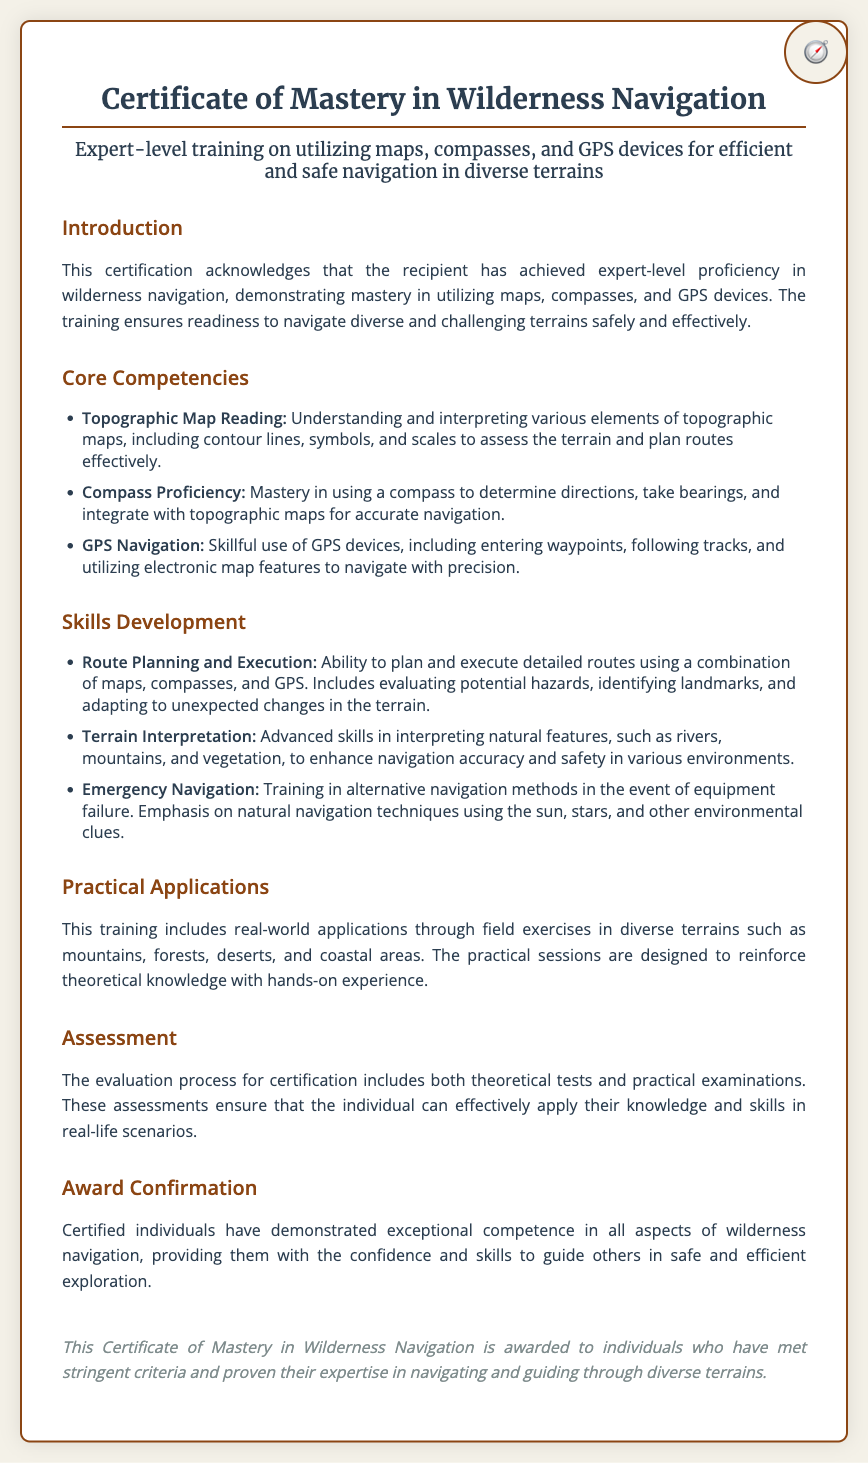What is the title of the certificate? The title is prominently displayed at the top of the document, indicating the purpose of the certification.
Answer: Certificate of Mastery in Wilderness Navigation What are the core competencies addressed? The document lists three core competencies under the corresponding section, providing insight into key skills.
Answer: Topographic Map Reading, Compass Proficiency, GPS Navigation How is assessment conducted for certification? The document specifies the evaluation process, noting the methods used to assess candidates.
Answer: Theoretical tests and practical examinations What is the focus of the training? The introductory section describes the main intent of the training provided through this certification.
Answer: Efficient and safe navigation in diverse terrains What does the emergency navigation training emphasize? The document outlines the focus of emergency navigation training, highlighting its content.
Answer: Natural navigation techniques using the sun, stars, and other environmental clues What type of document is this? This document serves a specific purpose in the field of skills training and recognition.
Answer: Certificate 